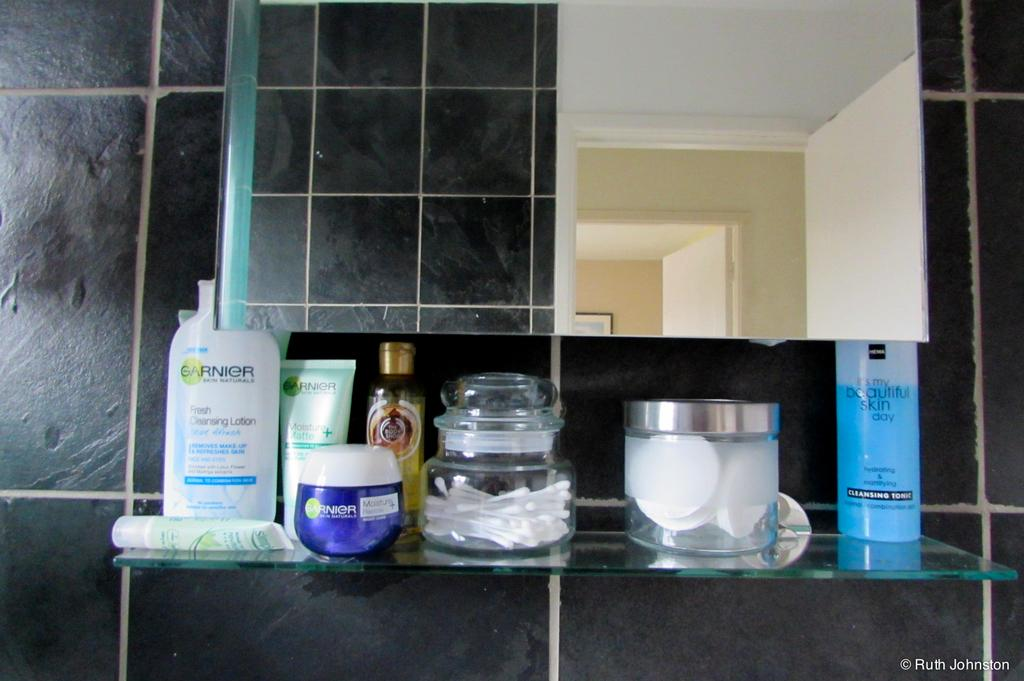<image>
Write a terse but informative summary of the picture. Personal beauty products line a glass shelf under a mirror, including two Garnier containers. 